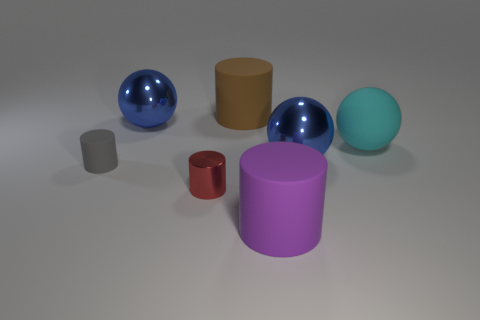Subtract 1 cylinders. How many cylinders are left? 3 Add 1 cyan rubber things. How many objects exist? 8 Subtract all green cylinders. Subtract all blue blocks. How many cylinders are left? 4 Subtract all cylinders. How many objects are left? 3 Add 4 big purple metal things. How many big purple metal things exist? 4 Subtract 0 yellow cylinders. How many objects are left? 7 Subtract all brown rubber things. Subtract all large cyan balls. How many objects are left? 5 Add 3 blue metal things. How many blue metal things are left? 5 